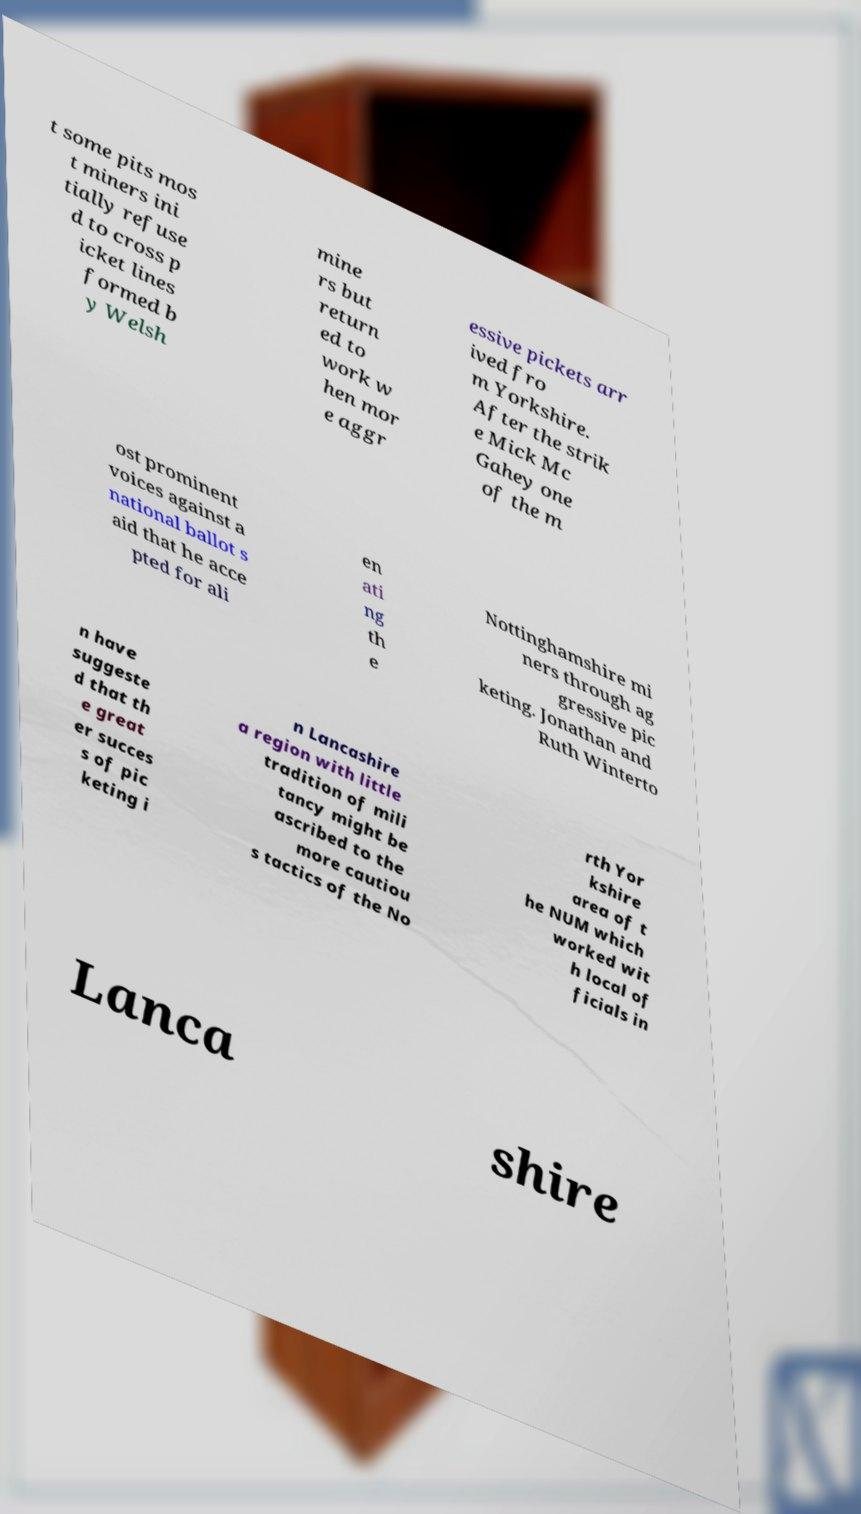Could you assist in decoding the text presented in this image and type it out clearly? t some pits mos t miners ini tially refuse d to cross p icket lines formed b y Welsh mine rs but return ed to work w hen mor e aggr essive pickets arr ived fro m Yorkshire. After the strik e Mick Mc Gahey one of the m ost prominent voices against a national ballot s aid that he acce pted for ali en ati ng th e Nottinghamshire mi ners through ag gressive pic keting. Jonathan and Ruth Winterto n have suggeste d that th e great er succes s of pic keting i n Lancashire a region with little tradition of mili tancy might be ascribed to the more cautiou s tactics of the No rth Yor kshire area of t he NUM which worked wit h local of ficials in Lanca shire 